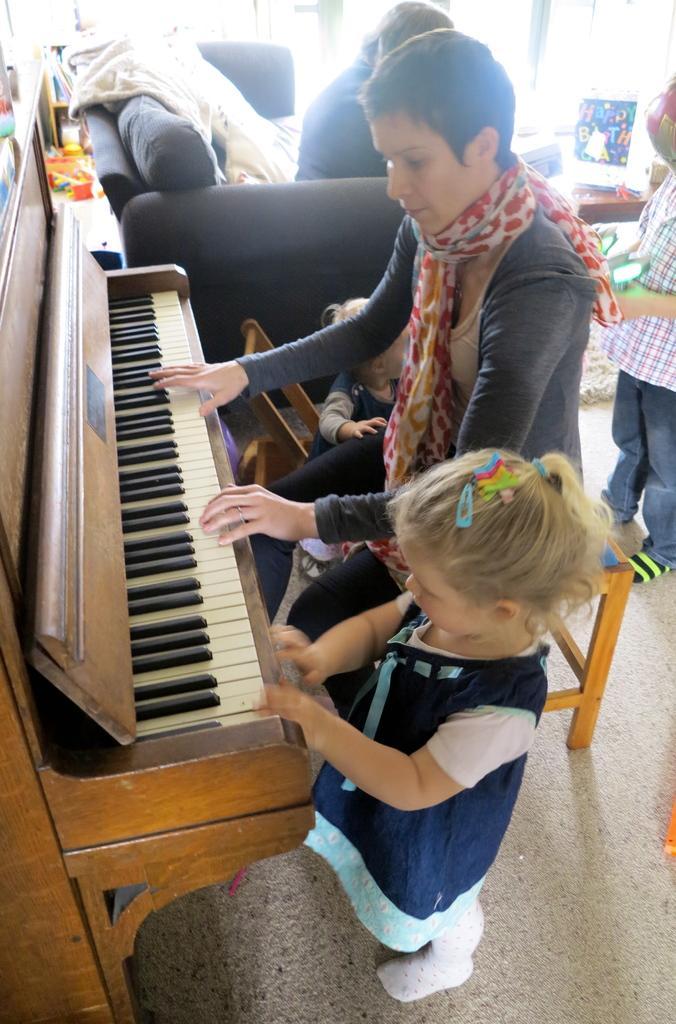How would you summarize this image in a sentence or two? In the image we can see there is a woman who is sitting and playing piano and there is a girl standing beside her. 